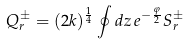Convert formula to latex. <formula><loc_0><loc_0><loc_500><loc_500>Q _ { r } ^ { \pm } = ( 2 k ) ^ { \frac { 1 } { 4 } } \oint d z \, e ^ { - \frac { \varphi } { 2 } } S _ { r } ^ { \pm }</formula> 